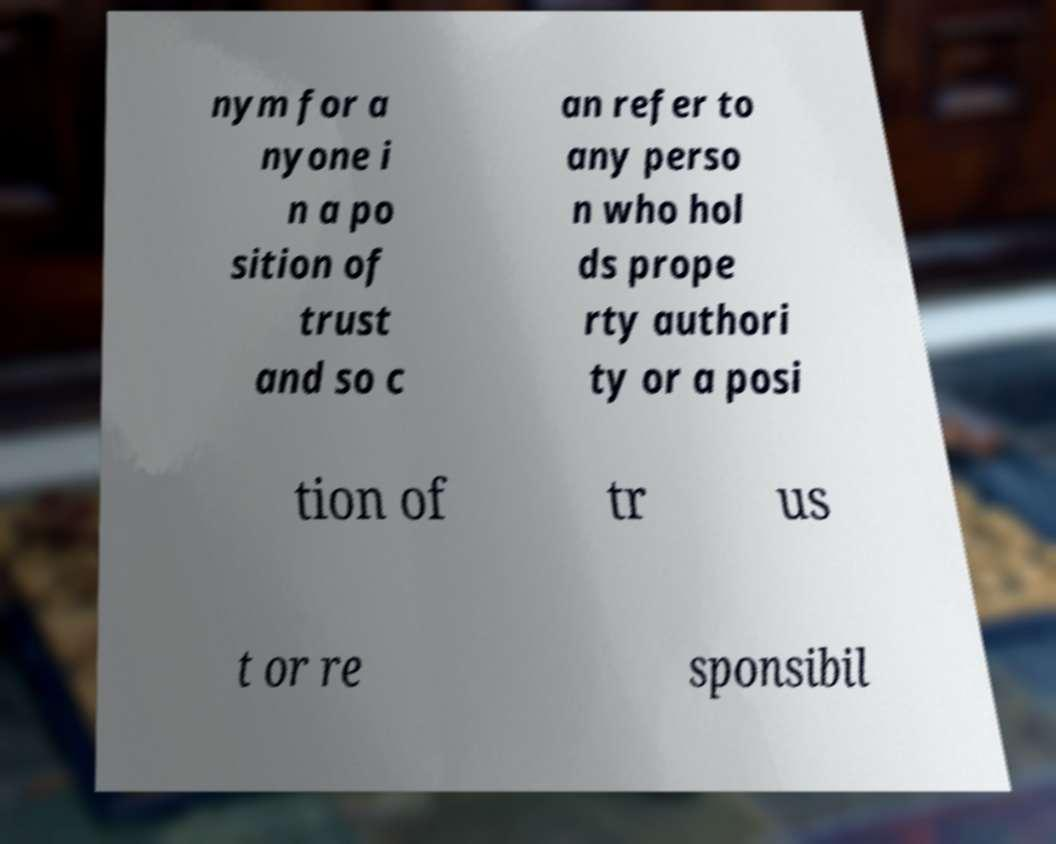Can you read and provide the text displayed in the image?This photo seems to have some interesting text. Can you extract and type it out for me? nym for a nyone i n a po sition of trust and so c an refer to any perso n who hol ds prope rty authori ty or a posi tion of tr us t or re sponsibil 